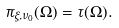<formula> <loc_0><loc_0><loc_500><loc_500>\pi _ { \xi , \nu _ { 0 } } ( \Omega ) = \tau ( \Omega ) .</formula> 